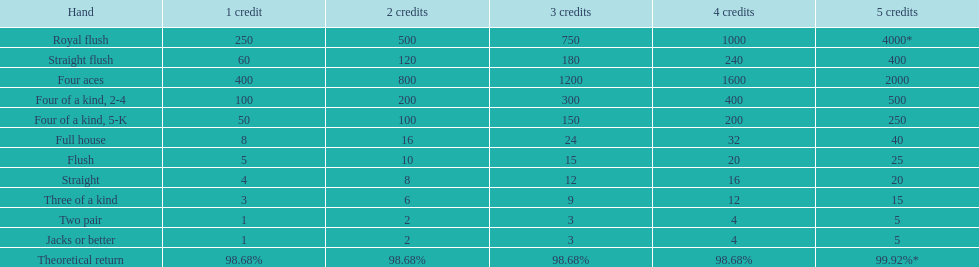What could be the highest earning for an individual possessing a full house? 40. 